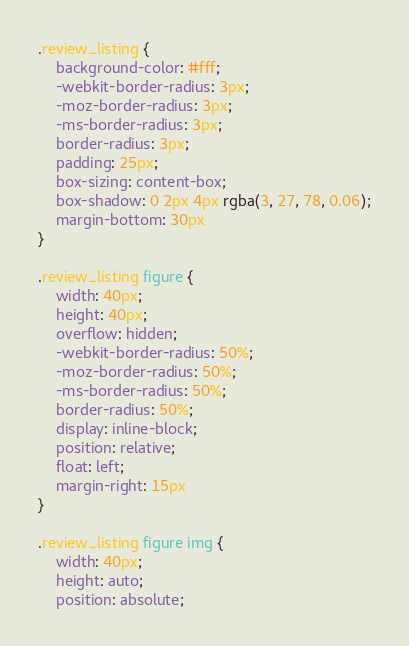<code> <loc_0><loc_0><loc_500><loc_500><_CSS_>.review_listing {
    background-color: #fff;
    -webkit-border-radius: 3px;
    -moz-border-radius: 3px;
    -ms-border-radius: 3px;
    border-radius: 3px;
    padding: 25px;
    box-sizing: content-box;
    box-shadow: 0 2px 4px rgba(3, 27, 78, 0.06);
    margin-bottom: 30px
}

.review_listing figure {
    width: 40px;
    height: 40px;
    overflow: hidden;
    -webkit-border-radius: 50%;
    -moz-border-radius: 50%;
    -ms-border-radius: 50%;
    border-radius: 50%;
    display: inline-block;
    position: relative;
    float: left;
    margin-right: 15px
}

.review_listing figure img {
    width: 40px;
    height: auto;
    position: absolute;</code> 